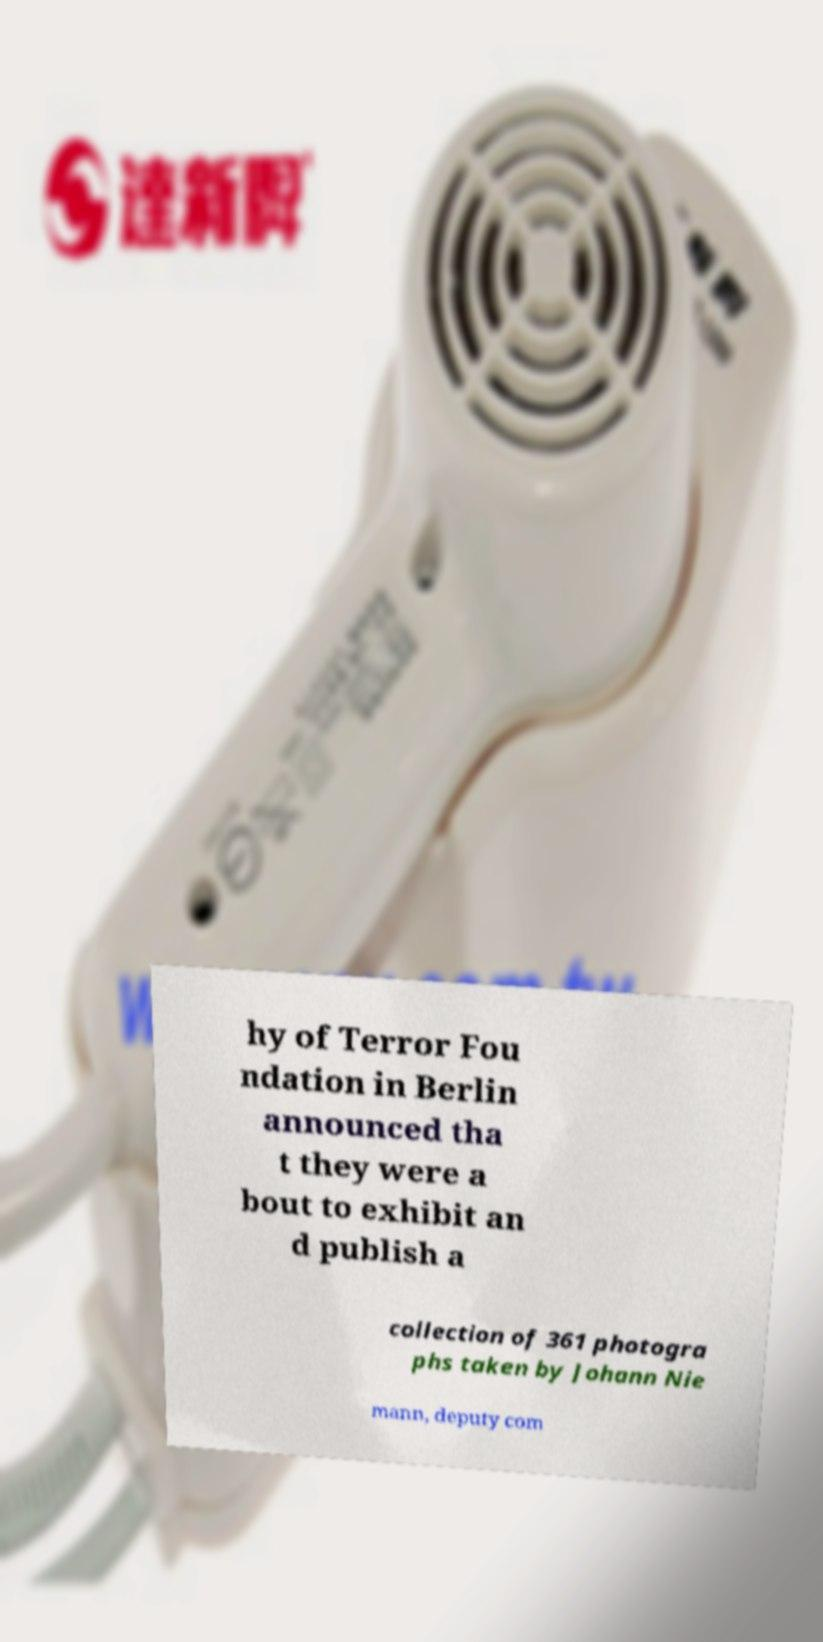There's text embedded in this image that I need extracted. Can you transcribe it verbatim? hy of Terror Fou ndation in Berlin announced tha t they were a bout to exhibit an d publish a collection of 361 photogra phs taken by Johann Nie mann, deputy com 